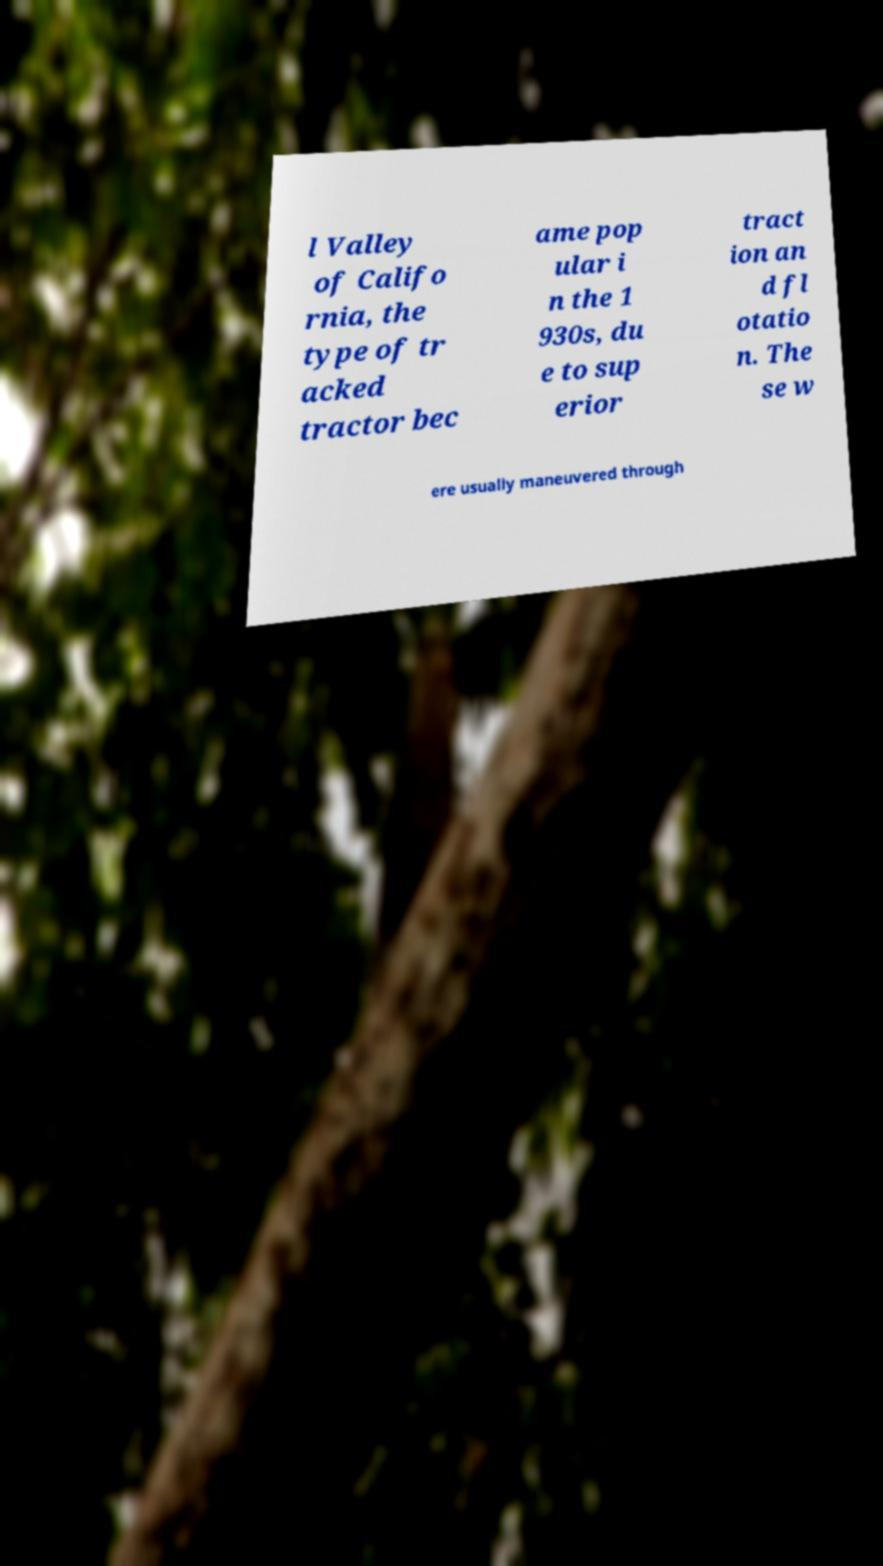Can you read and provide the text displayed in the image?This photo seems to have some interesting text. Can you extract and type it out for me? l Valley of Califo rnia, the type of tr acked tractor bec ame pop ular i n the 1 930s, du e to sup erior tract ion an d fl otatio n. The se w ere usually maneuvered through 